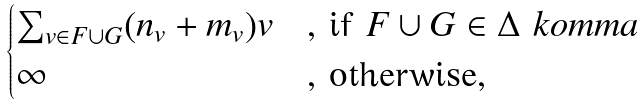<formula> <loc_0><loc_0><loc_500><loc_500>\begin{cases} \sum _ { v \in F \cup G } ( n _ { v } + m _ { v } ) v & \text {, if } F \cup G \in \Delta \ k o m m a \\ \infty & \text {, otherwise,} \end{cases}</formula> 